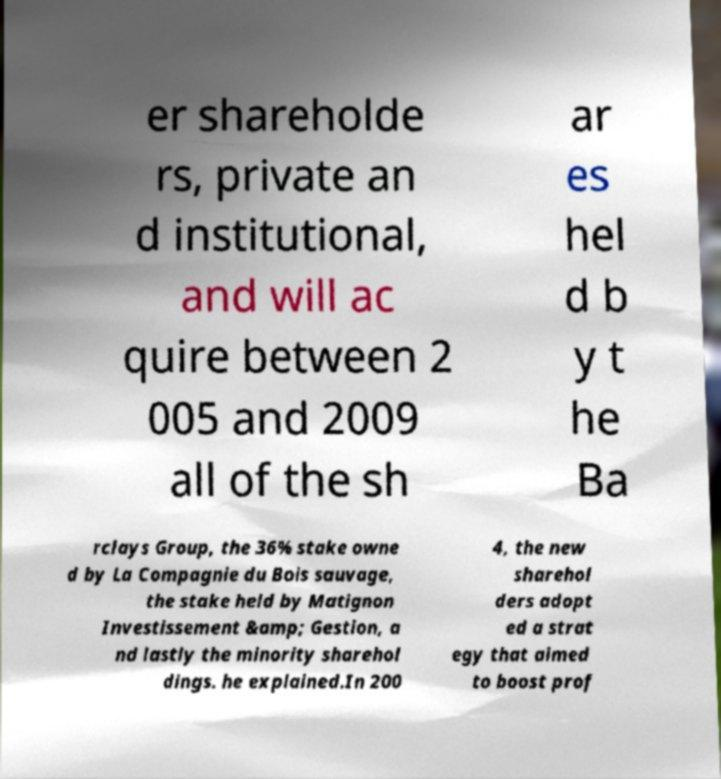I need the written content from this picture converted into text. Can you do that? er shareholde rs, private an d institutional, and will ac quire between 2 005 and 2009 all of the sh ar es hel d b y t he Ba rclays Group, the 36% stake owne d by La Compagnie du Bois sauvage, the stake held by Matignon Investissement &amp; Gestion, a nd lastly the minority sharehol dings. he explained.In 200 4, the new sharehol ders adopt ed a strat egy that aimed to boost prof 